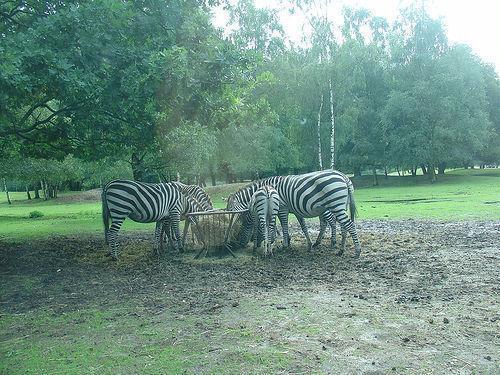These animals are mascots for what brand of gum?
Choose the correct response and explain in the format: 'Answer: answer
Rationale: rationale.'
Options: Doublemint, trident, dubble bubble, fruit stripe. Answer: fruit stripe.
Rationale: They are zebras. 